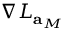<formula> <loc_0><loc_0><loc_500><loc_500>\nabla L _ { a _ { M } }</formula> 